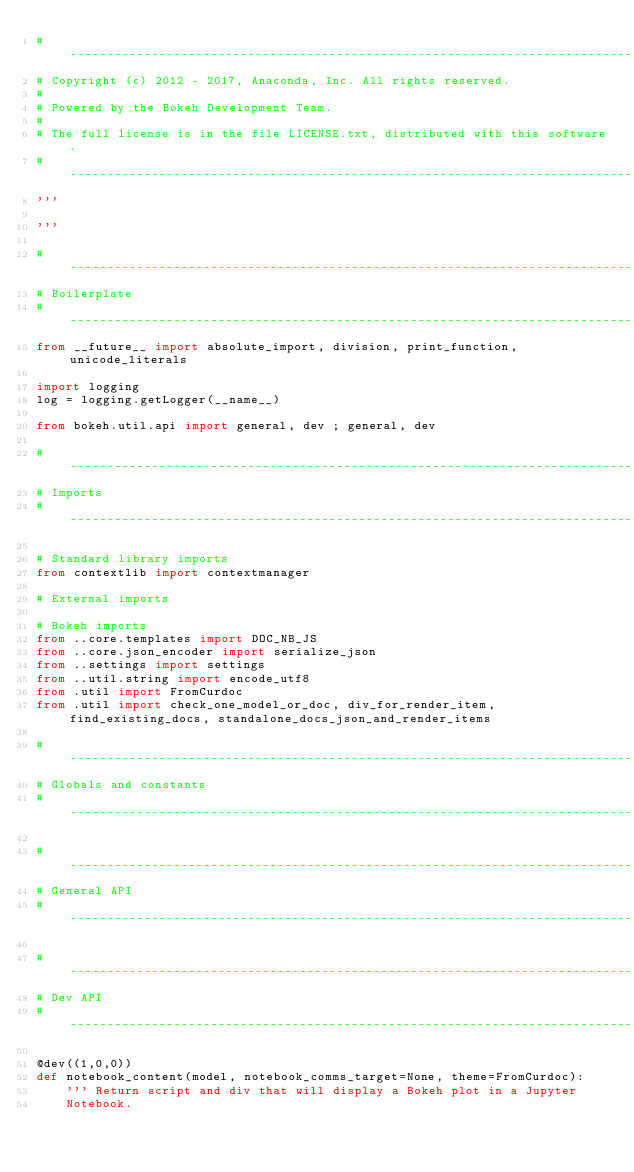<code> <loc_0><loc_0><loc_500><loc_500><_Python_>#-----------------------------------------------------------------------------
# Copyright (c) 2012 - 2017, Anaconda, Inc. All rights reserved.
#
# Powered by the Bokeh Development Team.
#
# The full license is in the file LICENSE.txt, distributed with this software.
#-----------------------------------------------------------------------------
'''

'''

#-----------------------------------------------------------------------------
# Boilerplate
#-----------------------------------------------------------------------------
from __future__ import absolute_import, division, print_function, unicode_literals

import logging
log = logging.getLogger(__name__)

from bokeh.util.api import general, dev ; general, dev

#-----------------------------------------------------------------------------
# Imports
#-----------------------------------------------------------------------------

# Standard library imports
from contextlib import contextmanager

# External imports

# Bokeh imports
from ..core.templates import DOC_NB_JS
from ..core.json_encoder import serialize_json
from ..settings import settings
from ..util.string import encode_utf8
from .util import FromCurdoc
from .util import check_one_model_or_doc, div_for_render_item, find_existing_docs, standalone_docs_json_and_render_items

#-----------------------------------------------------------------------------
# Globals and constants
#-----------------------------------------------------------------------------

#-----------------------------------------------------------------------------
# General API
#-----------------------------------------------------------------------------

#-----------------------------------------------------------------------------
# Dev API
#-----------------------------------------------------------------------------

@dev((1,0,0))
def notebook_content(model, notebook_comms_target=None, theme=FromCurdoc):
    ''' Return script and div that will display a Bokeh plot in a Jupyter
    Notebook.
</code> 